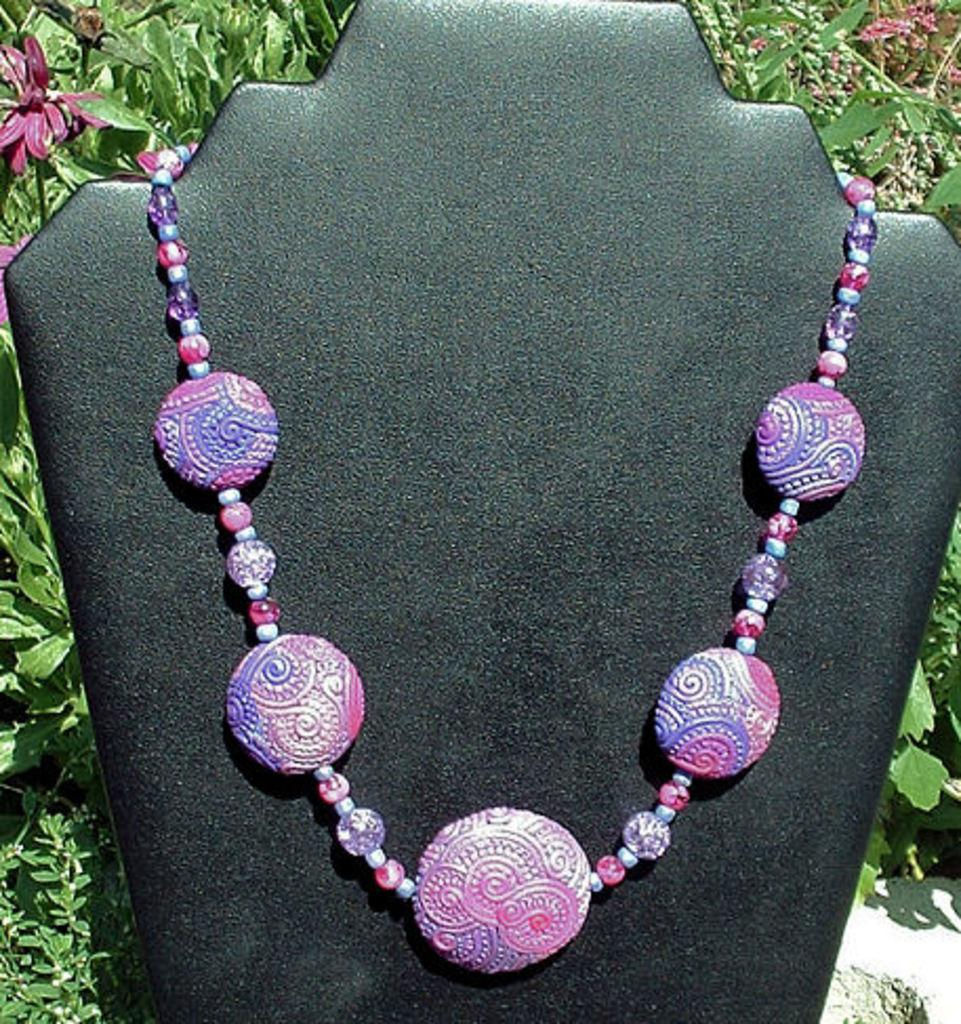What type of jewelry is in the image? There is a necklace in the image. What colors are present on the necklace? The necklace has blue and pink colors. What is the necklace placed on in the image? The necklace is placed on a black color sheet. What can be seen behind the sheet in the image? There are flowers and leaves behind the sheet. What type of slope is visible in the image? There is no slope present in the image; it features a necklace placed on a black color sheet with flowers and leaves in the background. 